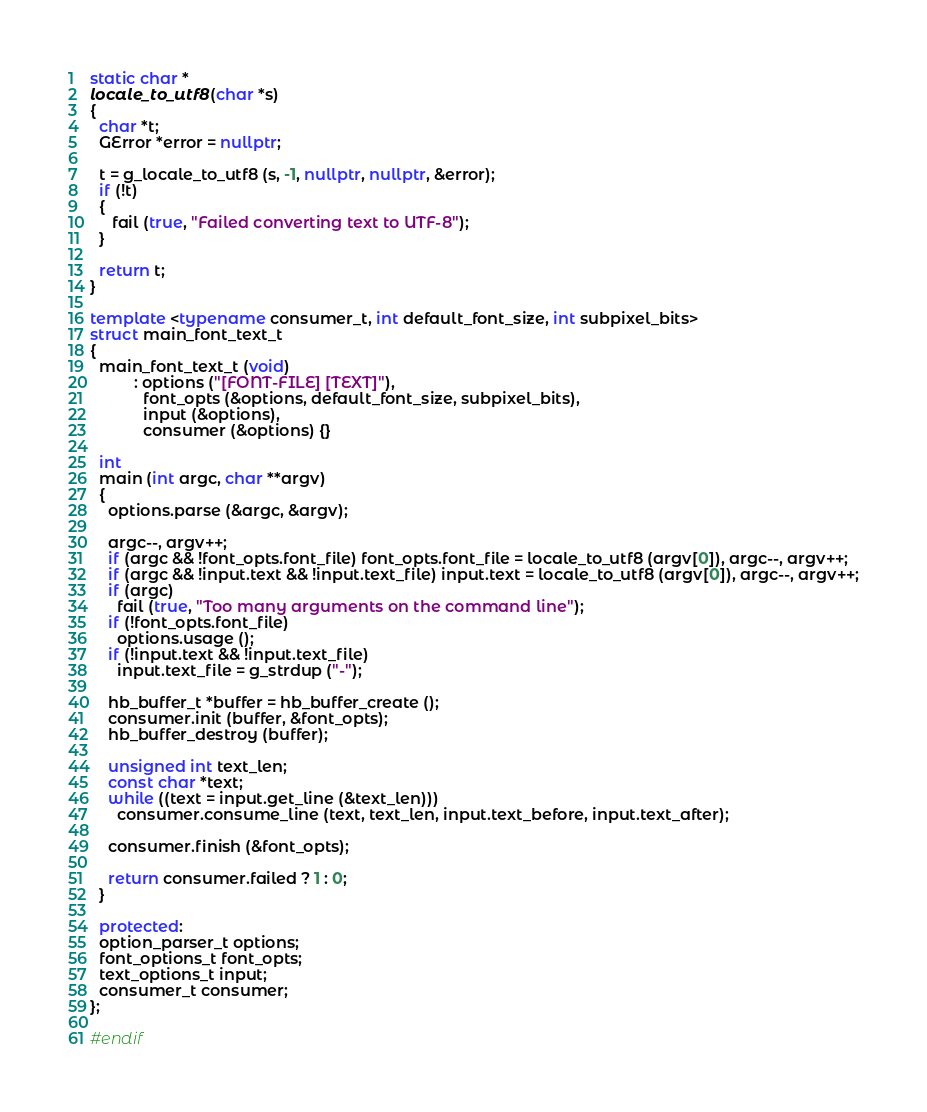<code> <loc_0><loc_0><loc_500><loc_500><_C++_>static char *
locale_to_utf8 (char *s)
{
  char *t;
  GError *error = nullptr;

  t = g_locale_to_utf8 (s, -1, nullptr, nullptr, &error);
  if (!t)
  {
     fail (true, "Failed converting text to UTF-8");
  }

  return t;
}

template <typename consumer_t, int default_font_size, int subpixel_bits>
struct main_font_text_t
{
  main_font_text_t (void)
		  : options ("[FONT-FILE] [TEXT]"),
		    font_opts (&options, default_font_size, subpixel_bits),
		    input (&options),
		    consumer (&options) {}

  int
  main (int argc, char **argv)
  {
    options.parse (&argc, &argv);

    argc--, argv++;
    if (argc && !font_opts.font_file) font_opts.font_file = locale_to_utf8 (argv[0]), argc--, argv++;
    if (argc && !input.text && !input.text_file) input.text = locale_to_utf8 (argv[0]), argc--, argv++;
    if (argc)
      fail (true, "Too many arguments on the command line");
    if (!font_opts.font_file)
      options.usage ();
    if (!input.text && !input.text_file)
      input.text_file = g_strdup ("-");

    hb_buffer_t *buffer = hb_buffer_create ();
    consumer.init (buffer, &font_opts);
    hb_buffer_destroy (buffer);

    unsigned int text_len;
    const char *text;
    while ((text = input.get_line (&text_len)))
      consumer.consume_line (text, text_len, input.text_before, input.text_after);

    consumer.finish (&font_opts);

    return consumer.failed ? 1 : 0;
  }

  protected:
  option_parser_t options;
  font_options_t font_opts;
  text_options_t input;
  consumer_t consumer;
};

#endif

</code> 